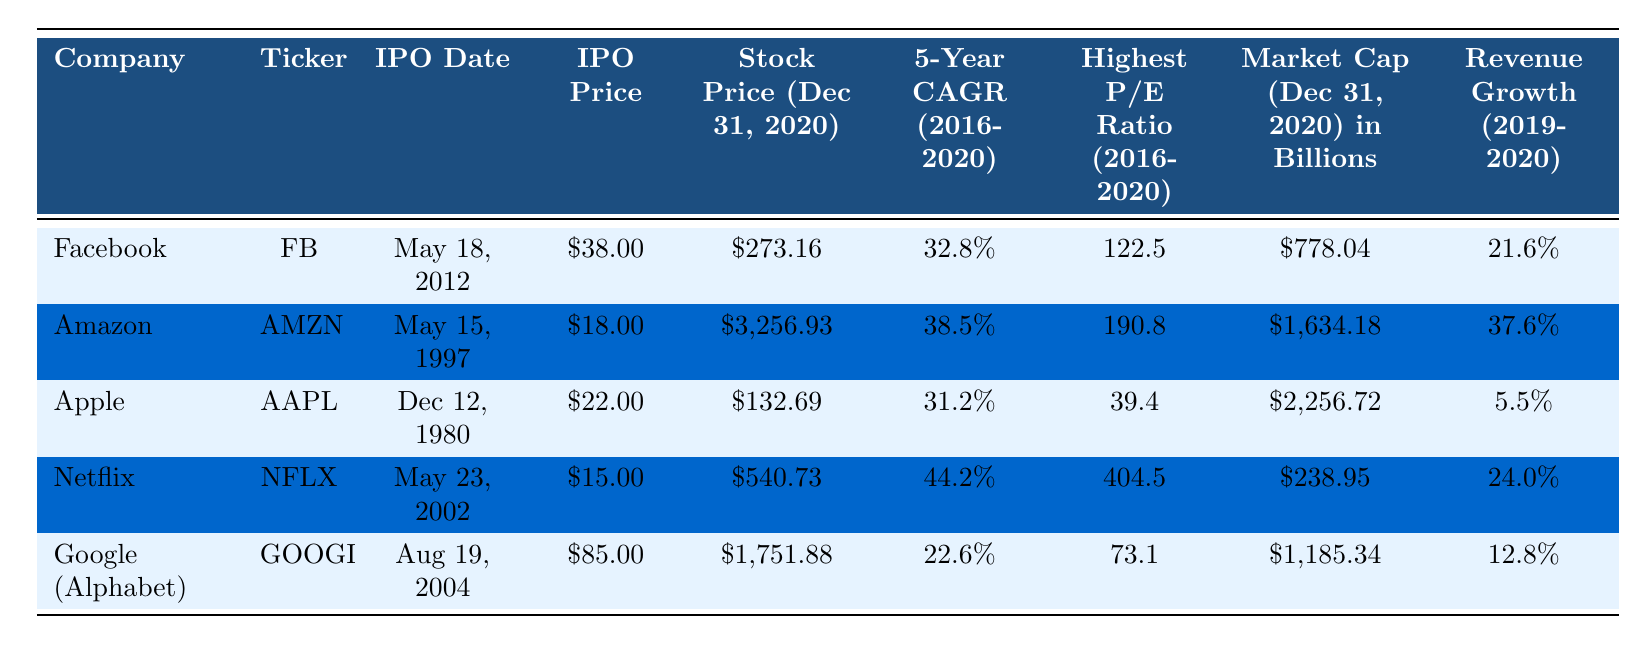What is the highest stock price for Amazon as of December 31, 2020? From the table, the stock price for Amazon on December 31, 2020, is listed as $3,256.93.
Answer: $3,256.93 Which company had the lowest revenue growth percentage from 2019 to 2020? Reviewing the revenue growth percentages, Facebook has 21.6%, Amazon has 37.6%, Apple shows 5.5%, Netflix at 24.0%, and Google's revenue growth is 12.8%. Apple has the lowest at 5.5%.
Answer: Apple What is the IPO price of Facebook? The IPO price for Facebook is explicitly stated in the table as $38.00.
Answer: $38.00 What was the average highest P/E ratio among the FAANG companies? The highest P/E ratios are 122.5 (Facebook), 190.8 (Amazon), 39.4 (Apple), 404.5 (Netflix), and 73.1 (Google). The sum is 830.3, and there are 5 companies, so the average P/E ratio is 830.3 / 5 = 166.06.
Answer: 166.06 True or False: Netflix had a higher stock price than Google (Alphabet) on December 31, 2020. From the table, Netflix's stock price is $540.73, while Google's is $1,751.88. $540.73 is less than $1,751.88, making the statement false.
Answer: False Which FAANG company had the highest revenue growth rate from 2019 to 2020? The table shows Amazon with a revenue growth of 37.6%, followed by Netflix at 24.0%. The others are lower, making Amazon the highest.
Answer: Amazon What is the difference in stock prices between the lowest and highest stock prices among FAANG companies as of December 31, 2020? The lowest stock price is Apple at $132.69 and the highest is Amazon at $3,256.93. The difference is $3,256.93 - $132.69 = $3,124.24.
Answer: $3,124.24 What is the market capitalization of Google (Alphabet) on December 31, 2020? The market cap for Google (Alphabet) is provided in the table as $1,185.34 billion.
Answer: $1,185.34 billion Which company had a 5-Year CAGR above 35%? The 5-Year CAGR for Facebook is 32.8%, Amazon is 38.5%, Apple is 31.2%, Netflix is 44.2%, and Google is 22.6%. Only Amazon and Netflix have CAGRs above 35%.
Answer: Amazon and Netflix What year was the IPO for Apple? The IPO date for Apple is listed in the table as December 12, 1980.
Answer: 1980 